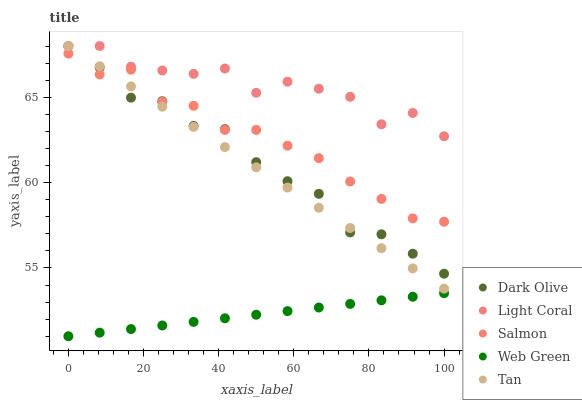Does Web Green have the minimum area under the curve?
Answer yes or no. Yes. Does Light Coral have the maximum area under the curve?
Answer yes or no. Yes. Does Tan have the minimum area under the curve?
Answer yes or no. No. Does Tan have the maximum area under the curve?
Answer yes or no. No. Is Web Green the smoothest?
Answer yes or no. Yes. Is Light Coral the roughest?
Answer yes or no. Yes. Is Tan the smoothest?
Answer yes or no. No. Is Tan the roughest?
Answer yes or no. No. Does Web Green have the lowest value?
Answer yes or no. Yes. Does Tan have the lowest value?
Answer yes or no. No. Does Dark Olive have the highest value?
Answer yes or no. Yes. Does Salmon have the highest value?
Answer yes or no. No. Is Web Green less than Dark Olive?
Answer yes or no. Yes. Is Light Coral greater than Salmon?
Answer yes or no. Yes. Does Tan intersect Dark Olive?
Answer yes or no. Yes. Is Tan less than Dark Olive?
Answer yes or no. No. Is Tan greater than Dark Olive?
Answer yes or no. No. Does Web Green intersect Dark Olive?
Answer yes or no. No. 